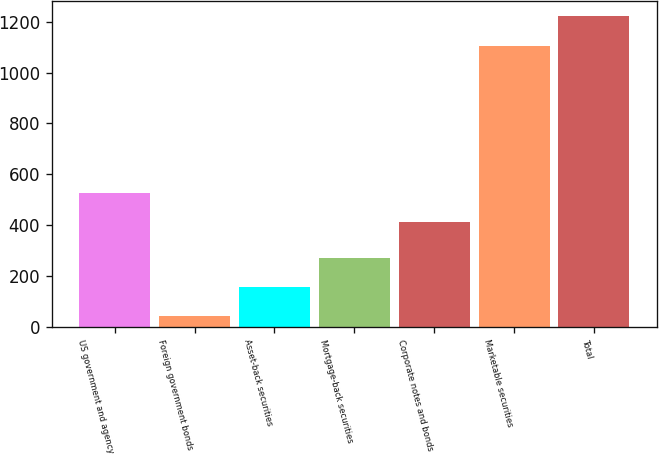<chart> <loc_0><loc_0><loc_500><loc_500><bar_chart><fcel>US government and agency<fcel>Foreign government bonds<fcel>Asset-back securities<fcel>Mortgage-back securities<fcel>Corporate notes and bonds<fcel>Marketable securities<fcel>Total<nl><fcel>526.53<fcel>41<fcel>156.43<fcel>271.86<fcel>411.1<fcel>1105.8<fcel>1221.23<nl></chart> 